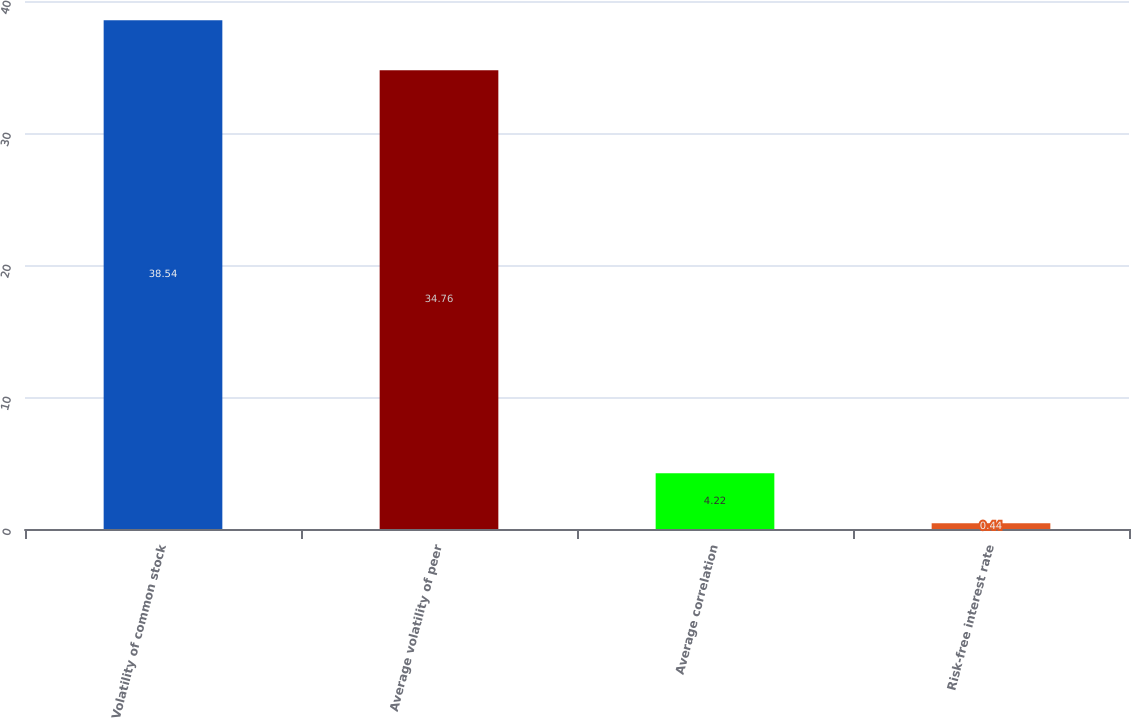Convert chart to OTSL. <chart><loc_0><loc_0><loc_500><loc_500><bar_chart><fcel>Volatility of common stock<fcel>Average volatility of peer<fcel>Average correlation<fcel>Risk-free interest rate<nl><fcel>38.54<fcel>34.76<fcel>4.22<fcel>0.44<nl></chart> 